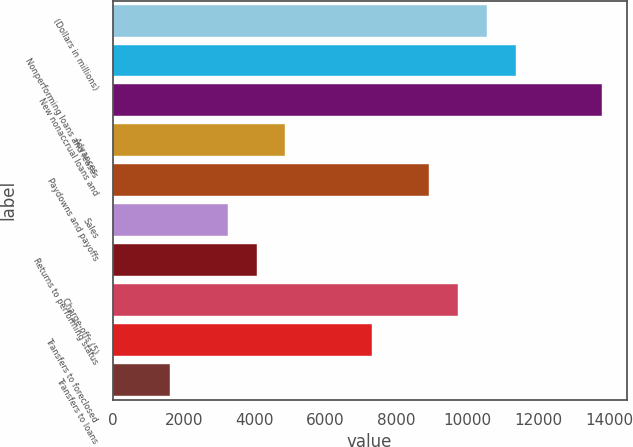Convert chart. <chart><loc_0><loc_0><loc_500><loc_500><bar_chart><fcel>(Dollars in millions)<fcel>Nonperforming loans and leases<fcel>New nonaccrual loans and<fcel>Advances<fcel>Paydowns and payoffs<fcel>Sales<fcel>Returns to performing status<fcel>Charge-offs (5)<fcel>Transfers to foreclosed<fcel>Transfers to loans<nl><fcel>10542.5<fcel>11353.3<fcel>13785.7<fcel>4866.79<fcel>8920.84<fcel>3245.17<fcel>4055.98<fcel>9731.65<fcel>7299.22<fcel>1623.55<nl></chart> 